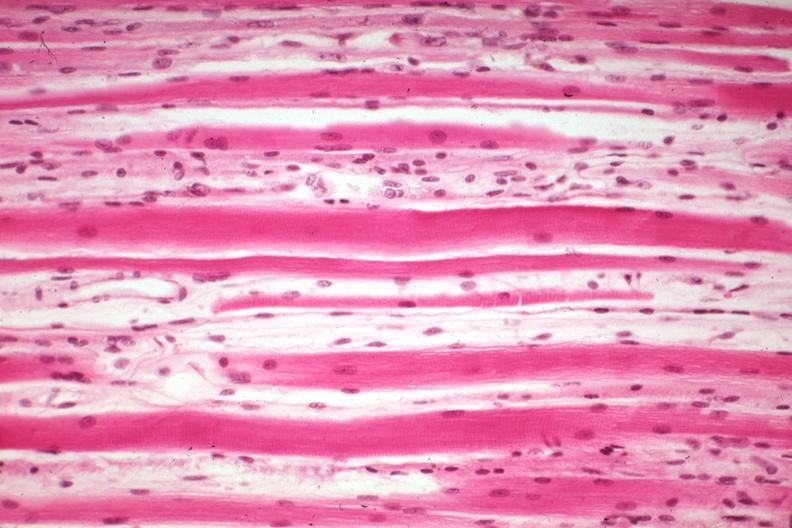s muscle present?
Answer the question using a single word or phrase. Yes 